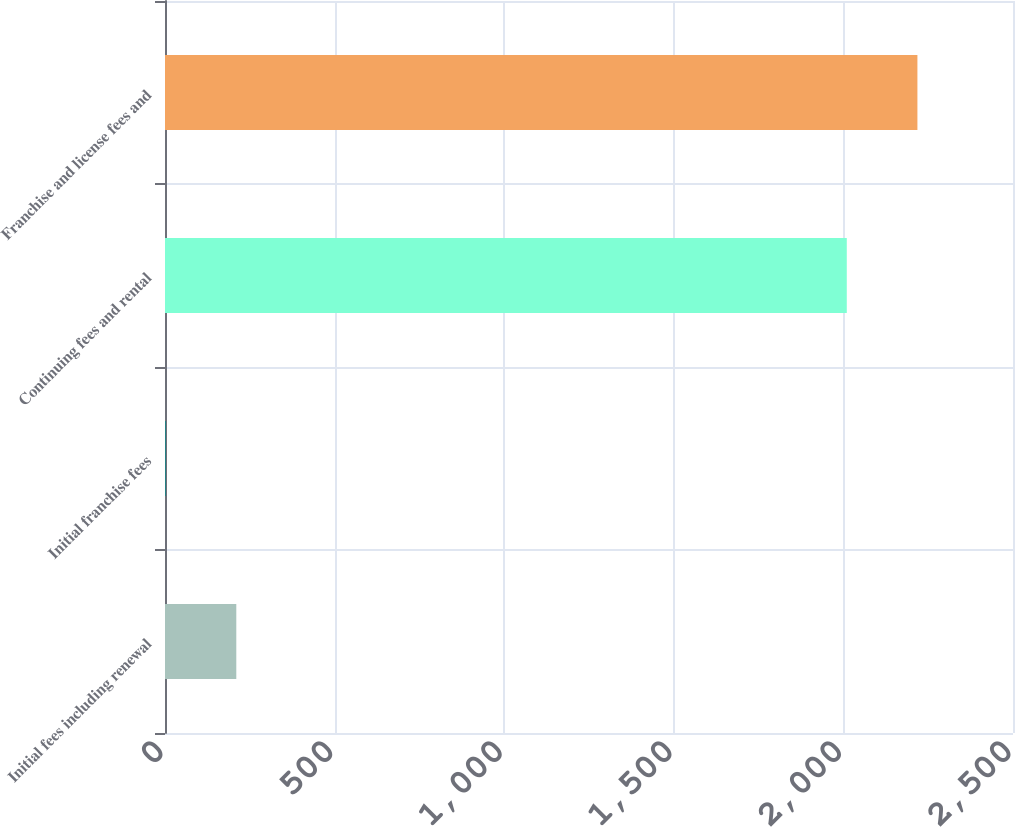Convert chart to OTSL. <chart><loc_0><loc_0><loc_500><loc_500><bar_chart><fcel>Initial fees including renewal<fcel>Initial franchise fees<fcel>Continuing fees and rental<fcel>Franchise and license fees and<nl><fcel>210.2<fcel>2<fcel>2010<fcel>2218.2<nl></chart> 